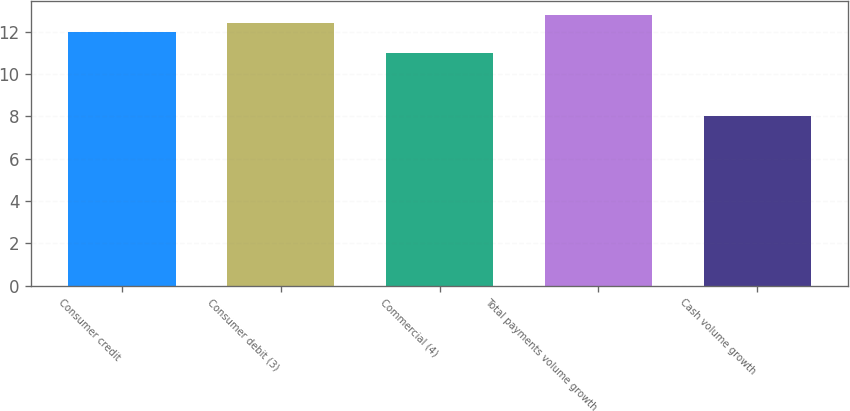Convert chart to OTSL. <chart><loc_0><loc_0><loc_500><loc_500><bar_chart><fcel>Consumer credit<fcel>Consumer debit (3)<fcel>Commercial (4)<fcel>Total payments volume growth<fcel>Cash volume growth<nl><fcel>12<fcel>12.4<fcel>11<fcel>12.8<fcel>8<nl></chart> 